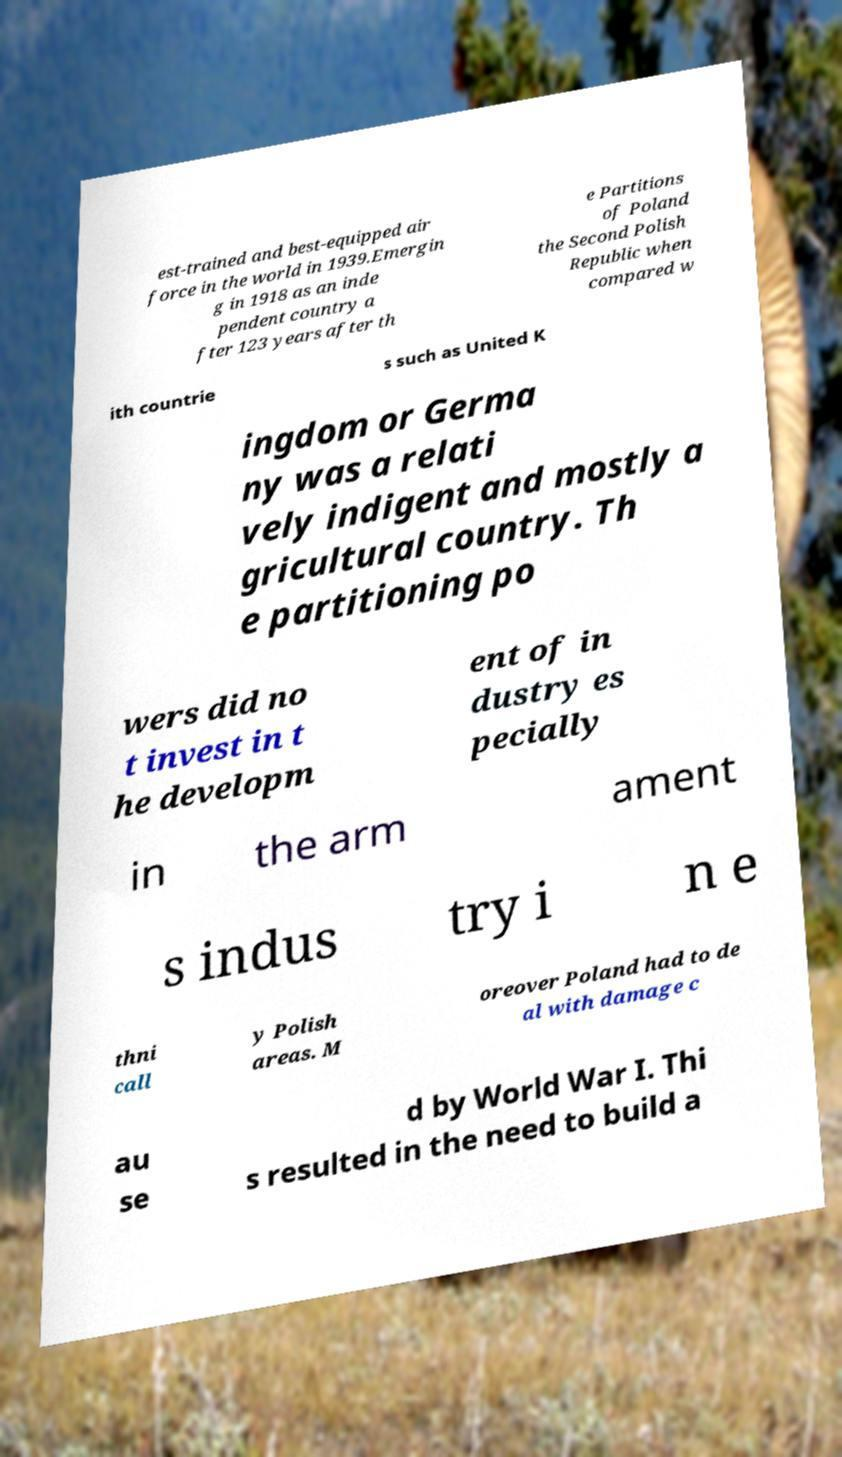Could you extract and type out the text from this image? est-trained and best-equipped air force in the world in 1939.Emergin g in 1918 as an inde pendent country a fter 123 years after th e Partitions of Poland the Second Polish Republic when compared w ith countrie s such as United K ingdom or Germa ny was a relati vely indigent and mostly a gricultural country. Th e partitioning po wers did no t invest in t he developm ent of in dustry es pecially in the arm ament s indus try i n e thni call y Polish areas. M oreover Poland had to de al with damage c au se d by World War I. Thi s resulted in the need to build a 